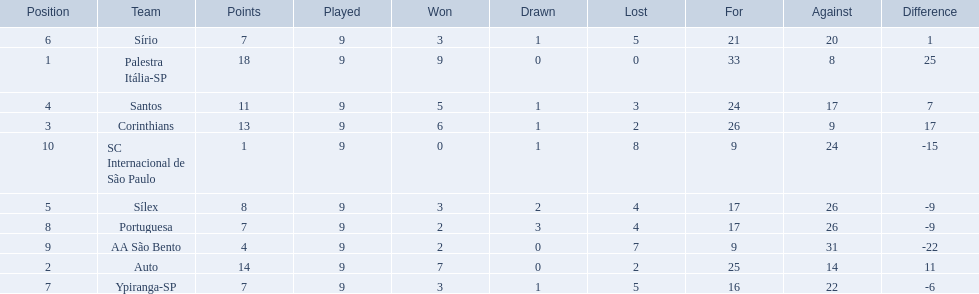Brazilian football in 1926 what teams had no draws? Palestra Itália-SP, Auto, AA São Bento. Of the teams with no draws name the 2 who lost the lease. Palestra Itália-SP, Auto. What team of the 2 who lost the least and had no draws had the highest difference? Palestra Itália-SP. 